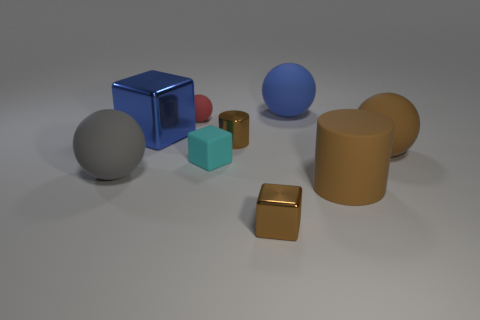Subtract all green spheres. Subtract all gray cubes. How many spheres are left? 4 Subtract all balls. How many objects are left? 5 Add 6 large cylinders. How many large cylinders exist? 7 Subtract 0 purple cubes. How many objects are left? 9 Subtract all matte spheres. Subtract all blue things. How many objects are left? 3 Add 7 large blue metal things. How many large blue metal things are left? 8 